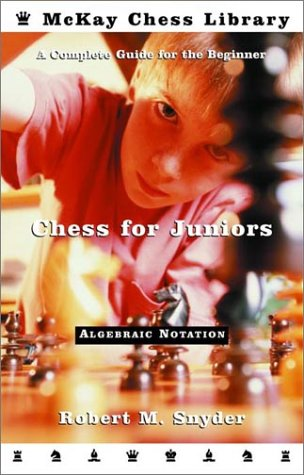What type of book is this? This book is specifically a chess instruction manual designed for young learners and beginners eager to understand and master the game of chess. 